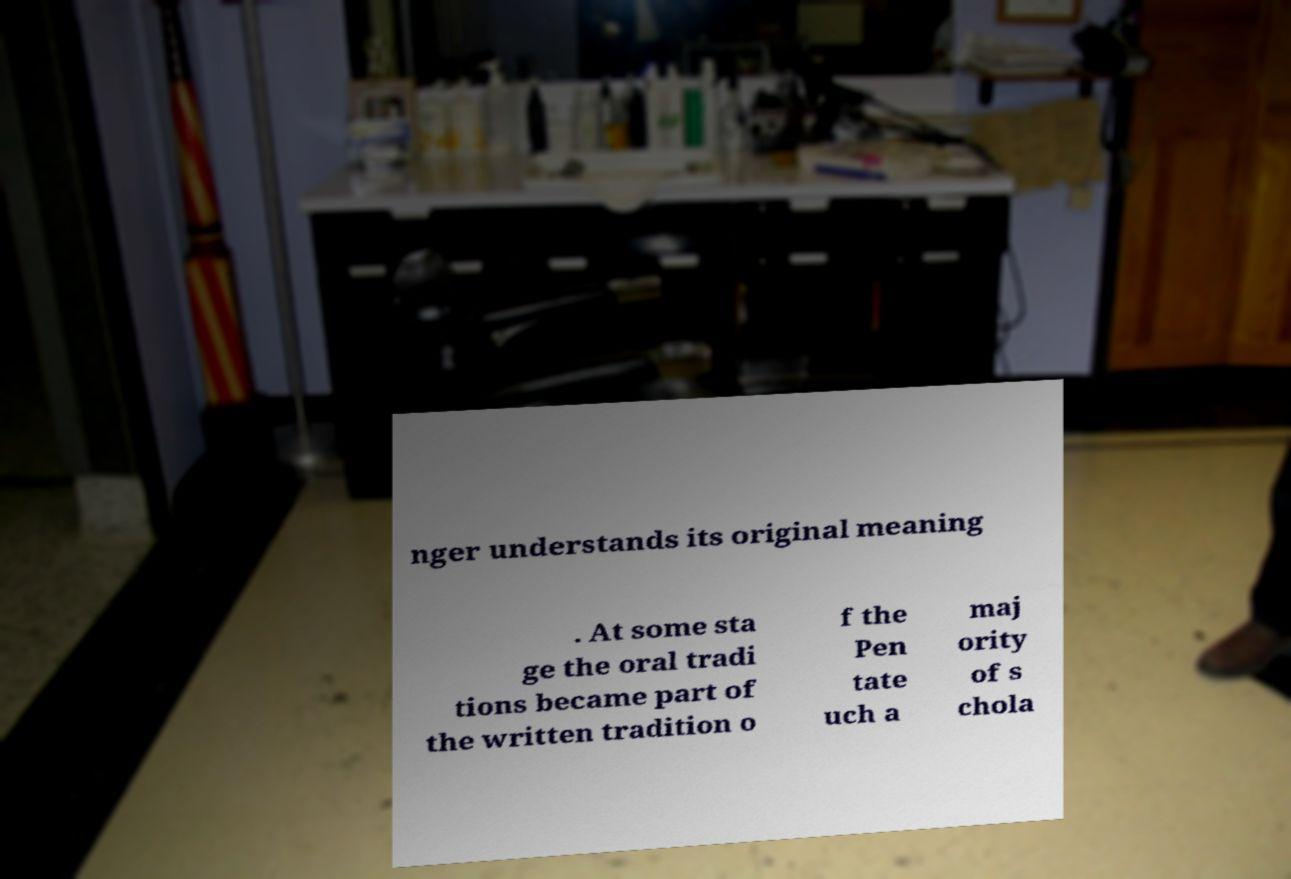I need the written content from this picture converted into text. Can you do that? nger understands its original meaning . At some sta ge the oral tradi tions became part of the written tradition o f the Pen tate uch a maj ority of s chola 